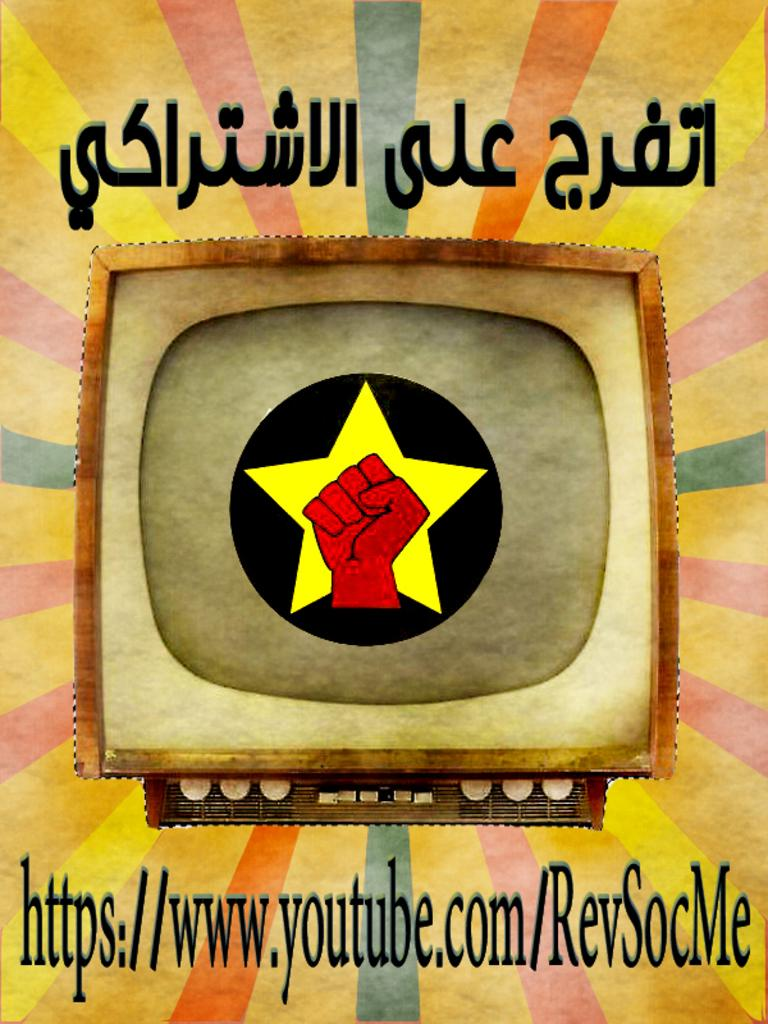<image>
Describe the image concisely. A colorful advertisement with a fist thrusted in front of a star inside of a tv screen linking to https://www.youtube.com/ReSocMe 